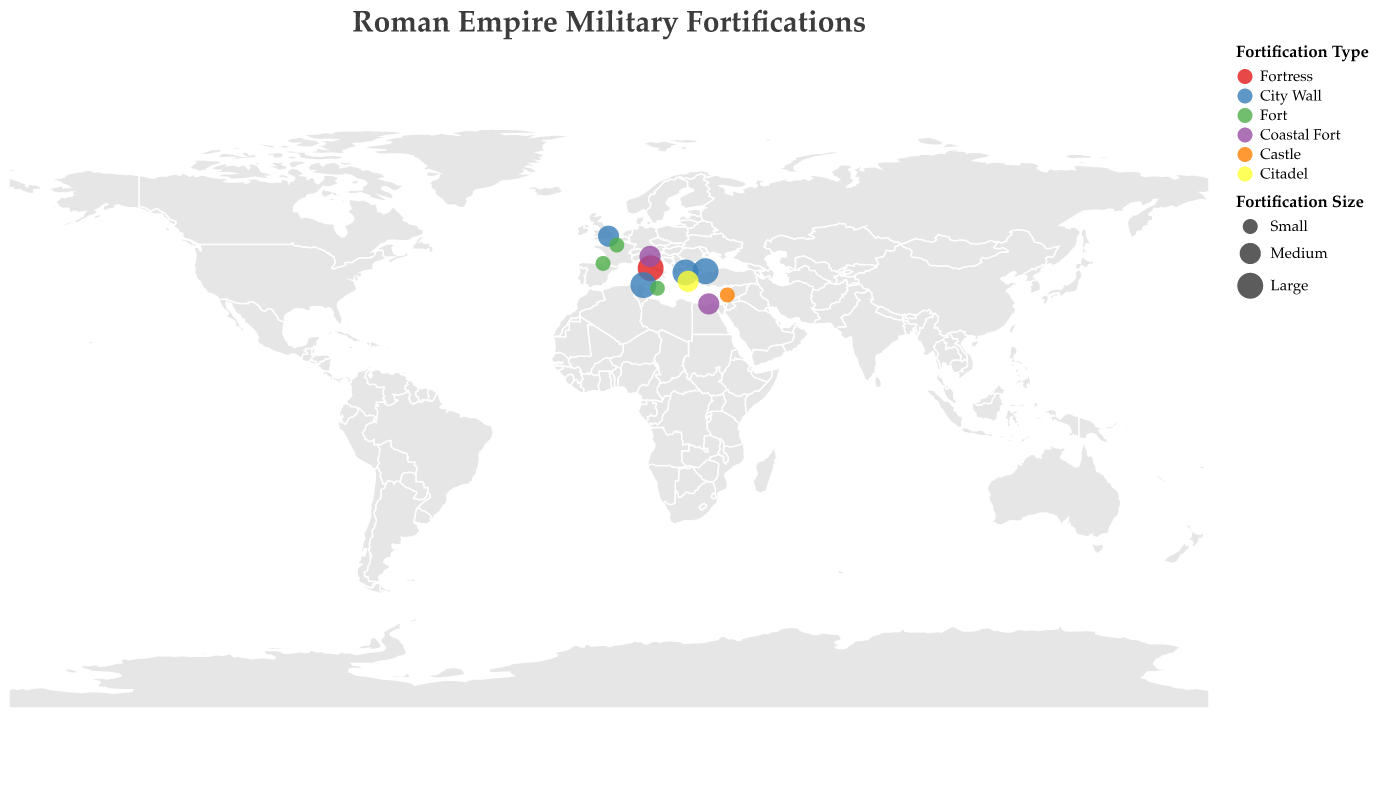What is the title of the figure? The title is located at the top of the figure and is usually directly stated as the heading of the entire visualization. The title says "Roman Empire Military Fortifications."
Answer: Roman Empire Military Fortifications What color represents Coastal Forts in the figure? The color legend for fortification types shows different color representations for each type. The Coastal Forts are represented by the color purple.
Answer: Purple How many small forts are shown in the figure? To determine the number of small forts, we look for data points with the Size labeled "Small." The data indicates there are: Lutetia Fortress, Lapurdum, Berytus Castle, and Melite Castrum.
Answer: 4 Which fortification type is most frequently large in size? By examining the color and size legend, we identify all large data points and their corresponding types. The types with large sizes are City Wall (Thessalonica Walls, Byzantium Walls, Carthage Walls).
Answer: City Wall What is the range of time periods covered by the fortifications? The data points all have a "Time Period" attribute, which can range from the earliest to the latest. The earliest period is 5th century BC (Athens Acropolis) and the latest is 15th century AD (Byzantium Walls).
Answer: 5th century BC-15th century AD Which fortification is located furthest east on the map? By inspecting the geographical coordinates (longitude and latitude), the fortification at the easternmost longitude is Berytus Castle with a longitude of 35.5018.
Answer: Berytus Castle What is the common characteristic of the fortifications found along coastal areas? Coastal fortifications are represented by their type as Coastal Fort. The common characteristic they share includes their medium size (Alexandria Pharos and Venetia Fortress).
Answer: Medium Size What is the difference in centuries between the oldest and the newest fortifications? The oldest fortification dates back to the 5th century BC (Athens Acropolis), and the most recent dates up to the 15th century AD (Byzantium Walls). The time span is 5th century BC to 15th century AD, which covers approximately 20 centuries.
Answer: 20 centuries Which city wall fortification endured until the 15th century AD? By examining the time periods of fortification types labeled as City Wall, only Byzantium Walls lasted until the 15th century AD.
Answer: Byzantium Walls 